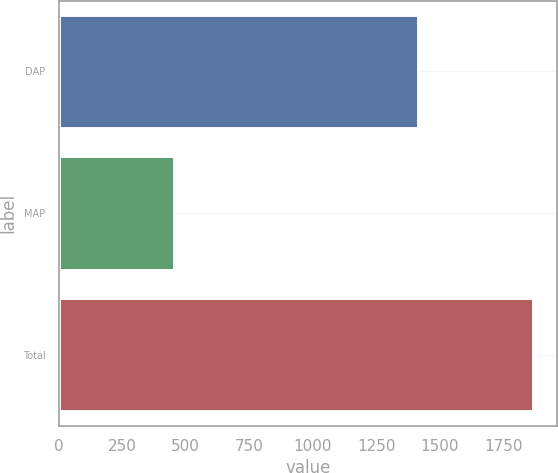Convert chart. <chart><loc_0><loc_0><loc_500><loc_500><bar_chart><fcel>DAP<fcel>MAP<fcel>Total<nl><fcel>1412<fcel>455<fcel>1867<nl></chart> 